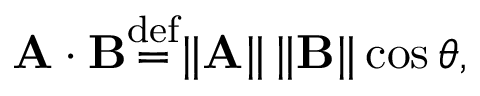<formula> <loc_0><loc_0><loc_500><loc_500>A \cdot B { \stackrel { d e f } { = } } \| A \| \, \| B \| \cos \theta ,</formula> 